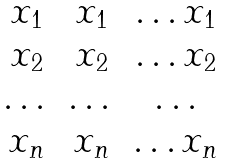<formula> <loc_0><loc_0><loc_500><loc_500>\begin{matrix} x _ { 1 } & x _ { 1 } & \dots x _ { 1 } \\ x _ { 2 } & x _ { 2 } & \dots x _ { 2 } \\ \dots & \dots & \dots \\ x _ { n } & x _ { n } & \dots x _ { n } \\ \end{matrix}</formula> 